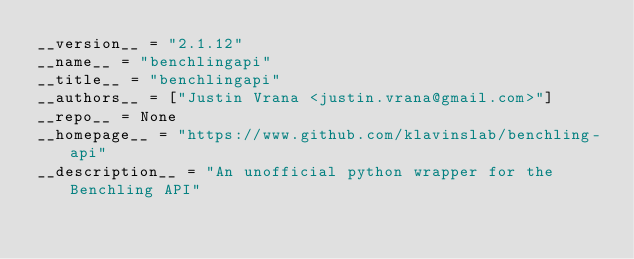<code> <loc_0><loc_0><loc_500><loc_500><_Python_>__version__ = "2.1.12"
__name__ = "benchlingapi"
__title__ = "benchlingapi"
__authors__ = ["Justin Vrana <justin.vrana@gmail.com>"]
__repo__ = None
__homepage__ = "https://www.github.com/klavinslab/benchling-api"
__description__ = "An unofficial python wrapper for the Benchling API"
</code> 